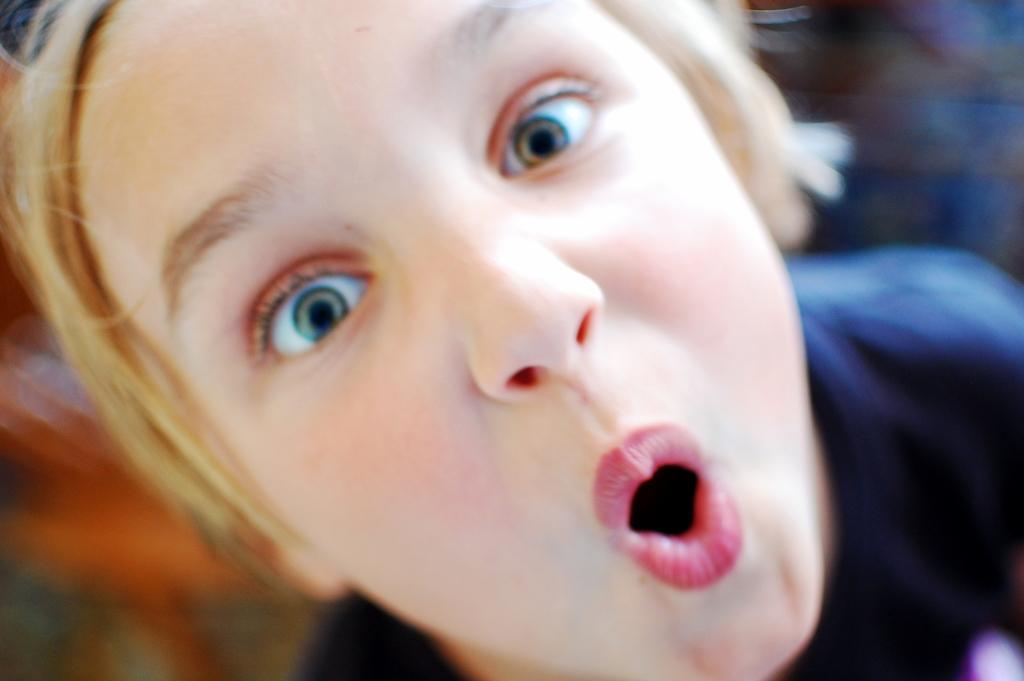Describe this image in one or two sentences. In this picture we can see a person and behind the person there is blurred background. 